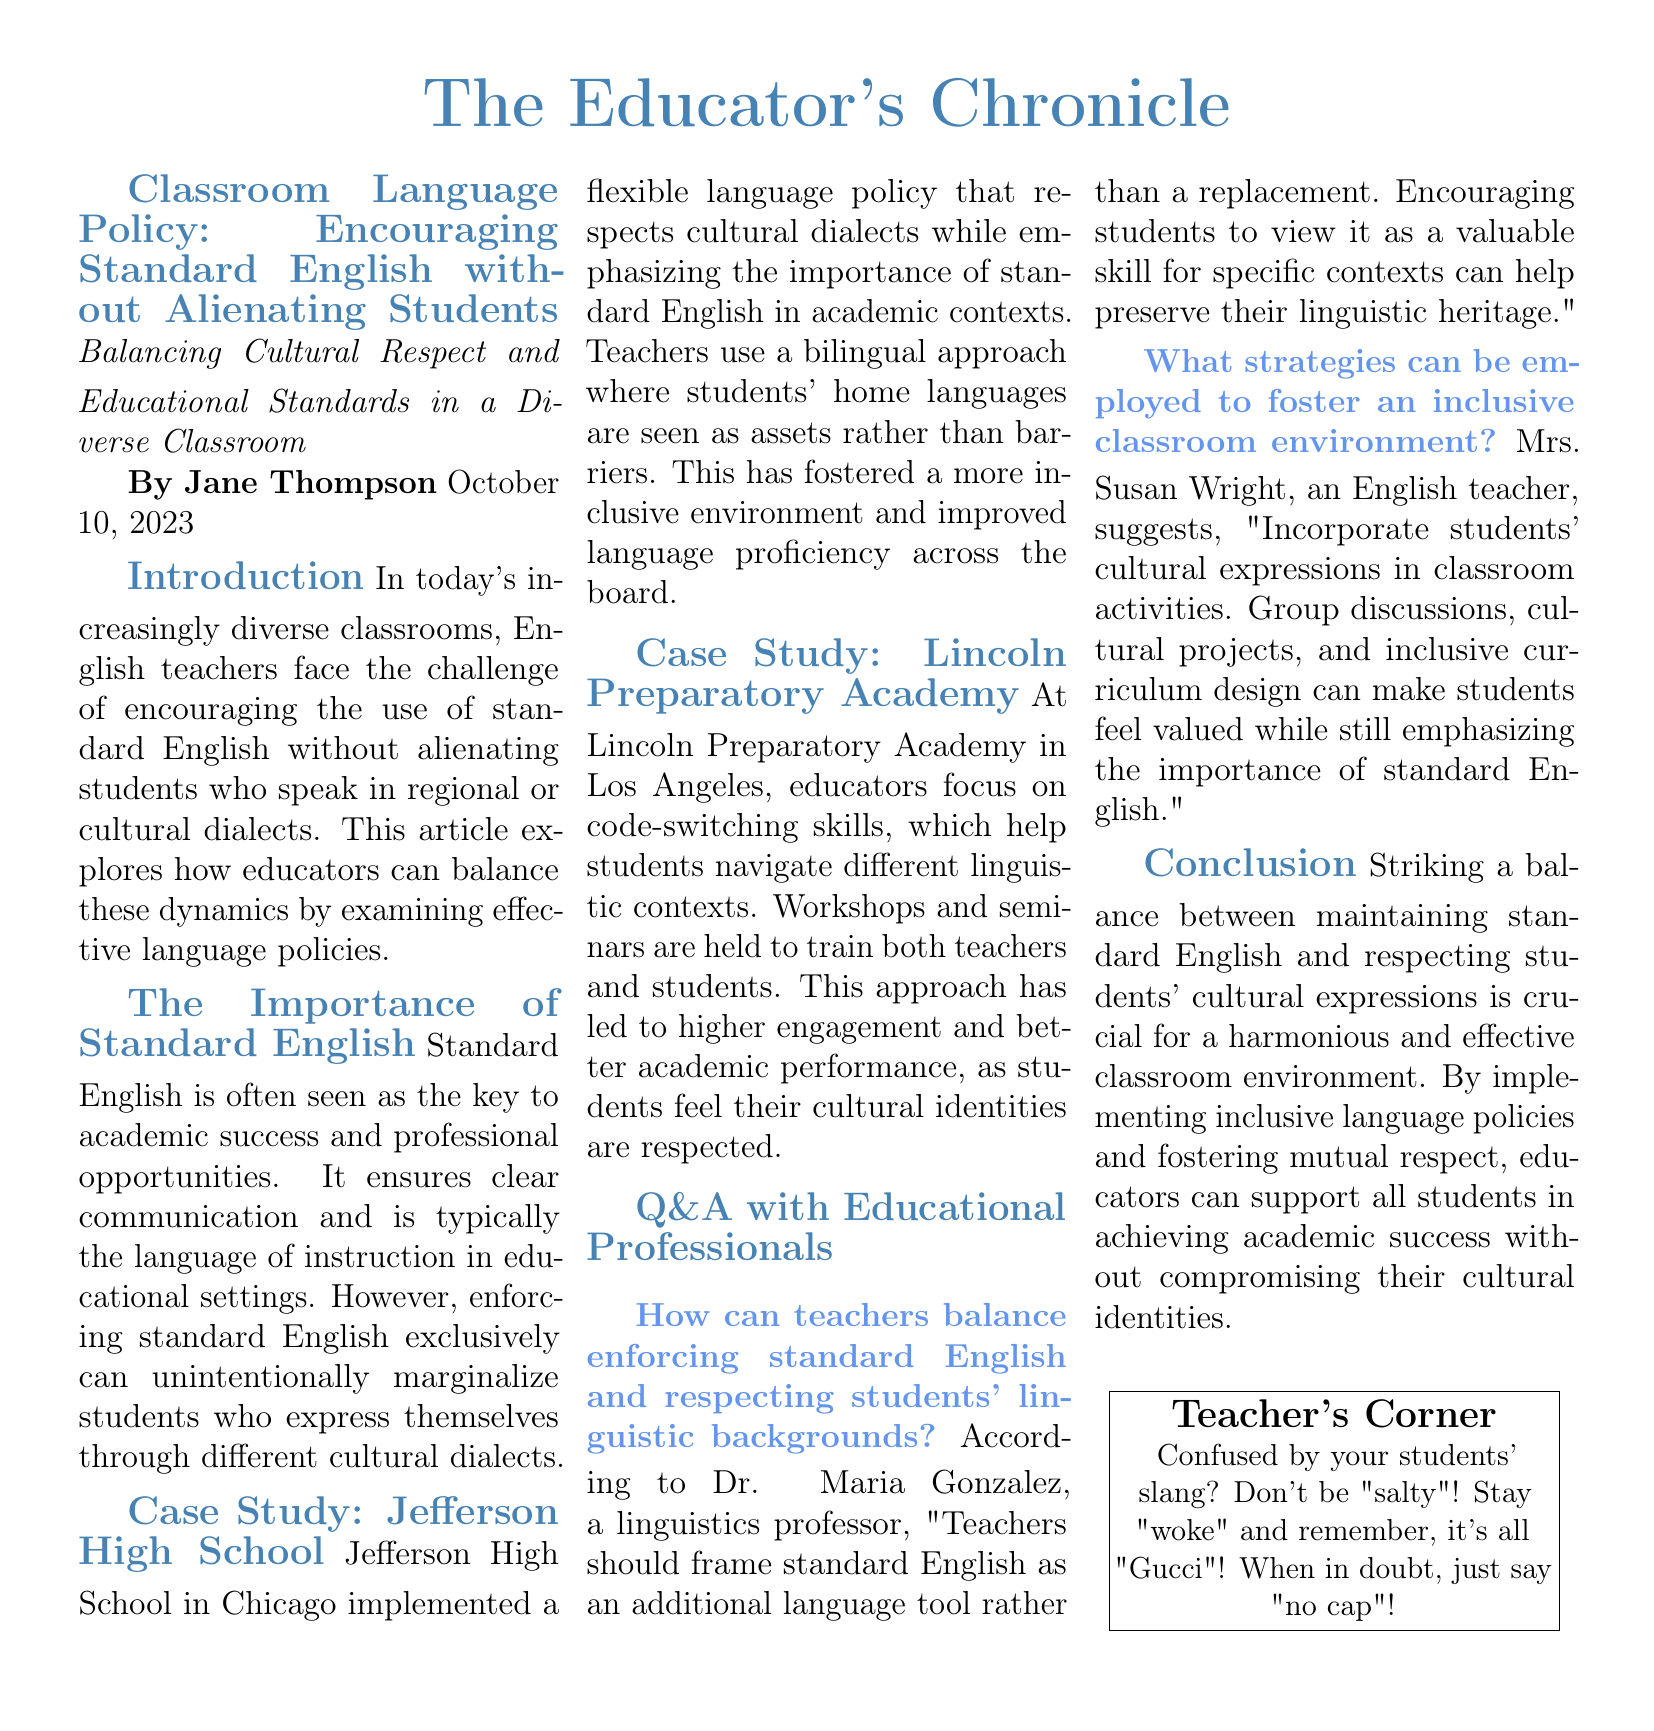What is the title of the article? The title of the article is stated at the beginning, highlighting the focus on classroom language policy.
Answer: Classroom Language Policy: Encouraging Standard English without Alienating Students Who is the author of the article? The author of the article is mentioned right below the title, providing insight into its authorship.
Answer: Jane Thompson What date was the article published? The publication date is noted alongside the author's name, indicating when the article was released.
Answer: October 10, 2023 What school is mentioned in the first case study? A specific school is referenced in the case study to illustrate effective language policy.
Answer: Jefferson High School What approach is emphasized at Lincoln Preparatory Academy? The article describes a particular skill that is a focus in the second case study concerning language usage.
Answer: Code-switching skills Who suggests incorporating students’ cultural expressions in classroom activities? A specific individual is quoted, offering a strategy for fostering inclusivity in the classroom.
Answer: Mrs. Susan Wright What framing does Dr. Maria Gonzalez propose regarding standard English? The article quotes an expert suggesting a perspective on how standard English should be viewed by students.
Answer: An additional language tool What is the primary goal of implementing inclusive language policies? The article articulates a fundamental aim of the proposals discussed within the classroom language policy.
Answer: Support all students in achieving academic success What does the "Teacher's Corner" highlight for teachers confused by slang? This section provides a reminder or encouragement for teachers facing challenges understanding slang.
Answer: Stay "woke" 